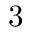<formula> <loc_0><loc_0><loc_500><loc_500>3</formula> 